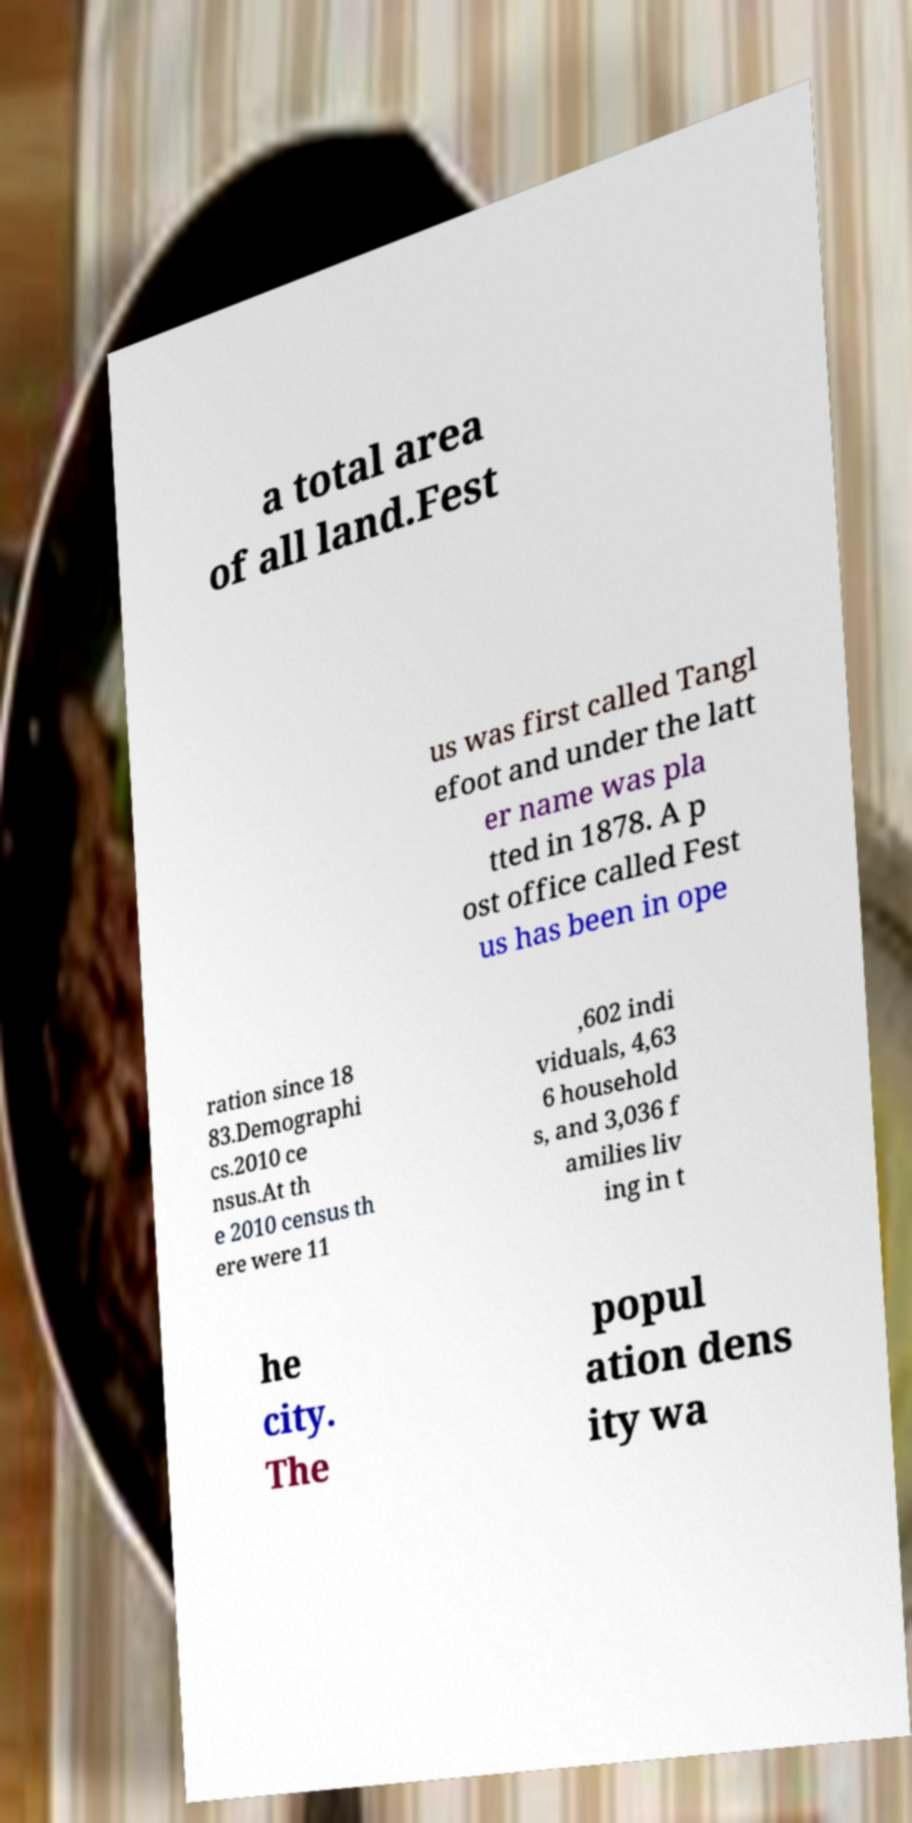I need the written content from this picture converted into text. Can you do that? a total area of all land.Fest us was first called Tangl efoot and under the latt er name was pla tted in 1878. A p ost office called Fest us has been in ope ration since 18 83.Demographi cs.2010 ce nsus.At th e 2010 census th ere were 11 ,602 indi viduals, 4,63 6 household s, and 3,036 f amilies liv ing in t he city. The popul ation dens ity wa 